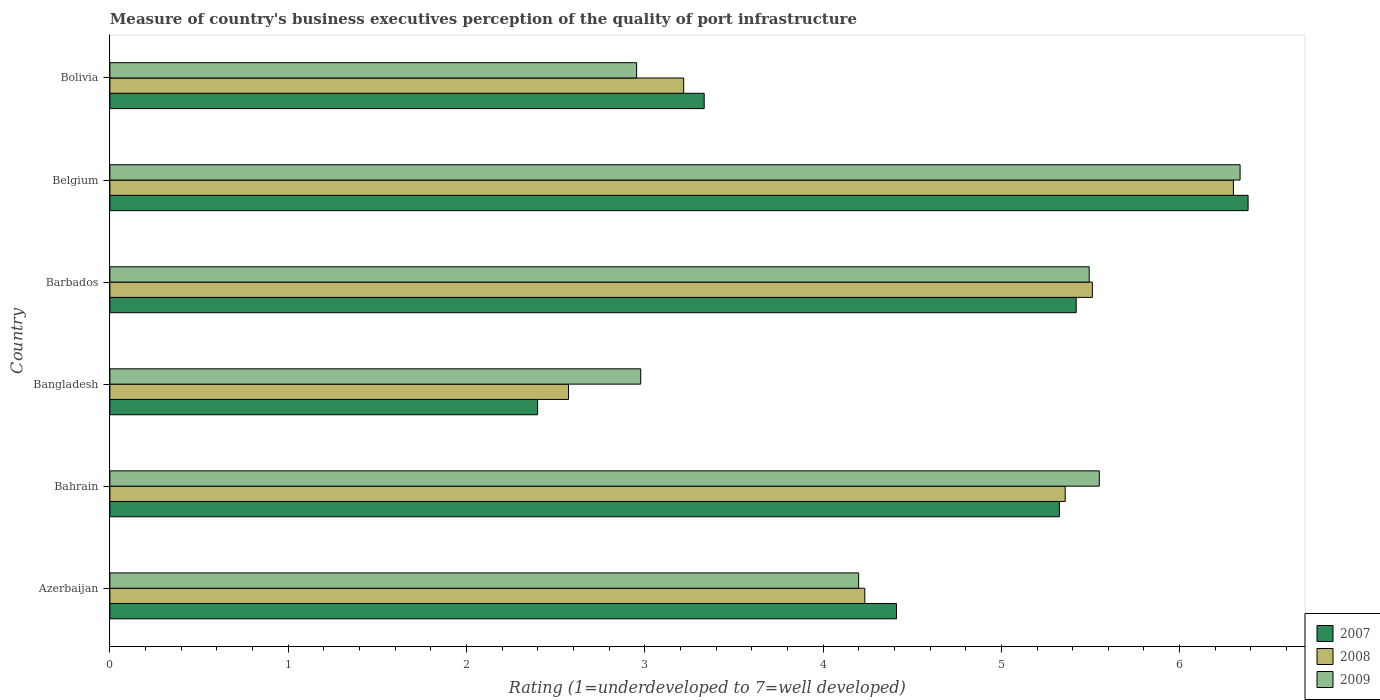How many groups of bars are there?
Your response must be concise. 6. Are the number of bars per tick equal to the number of legend labels?
Ensure brevity in your answer.  Yes. What is the label of the 6th group of bars from the top?
Offer a terse response. Azerbaijan. In how many cases, is the number of bars for a given country not equal to the number of legend labels?
Your answer should be compact. 0. What is the ratings of the quality of port infrastructure in 2008 in Bangladesh?
Give a very brief answer. 2.57. Across all countries, what is the maximum ratings of the quality of port infrastructure in 2009?
Your response must be concise. 6.34. Across all countries, what is the minimum ratings of the quality of port infrastructure in 2008?
Give a very brief answer. 2.57. In which country was the ratings of the quality of port infrastructure in 2008 maximum?
Make the answer very short. Belgium. What is the total ratings of the quality of port infrastructure in 2008 in the graph?
Give a very brief answer. 27.2. What is the difference between the ratings of the quality of port infrastructure in 2007 in Bangladesh and that in Belgium?
Ensure brevity in your answer.  -3.98. What is the difference between the ratings of the quality of port infrastructure in 2009 in Bangladesh and the ratings of the quality of port infrastructure in 2007 in Bolivia?
Offer a very short reply. -0.36. What is the average ratings of the quality of port infrastructure in 2009 per country?
Keep it short and to the point. 4.59. What is the difference between the ratings of the quality of port infrastructure in 2009 and ratings of the quality of port infrastructure in 2007 in Bolivia?
Your answer should be very brief. -0.38. What is the ratio of the ratings of the quality of port infrastructure in 2009 in Azerbaijan to that in Belgium?
Provide a short and direct response. 0.66. Is the ratings of the quality of port infrastructure in 2008 in Bahrain less than that in Bangladesh?
Give a very brief answer. No. Is the difference between the ratings of the quality of port infrastructure in 2009 in Barbados and Bolivia greater than the difference between the ratings of the quality of port infrastructure in 2007 in Barbados and Bolivia?
Give a very brief answer. Yes. What is the difference between the highest and the second highest ratings of the quality of port infrastructure in 2008?
Keep it short and to the point. 0.79. What is the difference between the highest and the lowest ratings of the quality of port infrastructure in 2008?
Your answer should be very brief. 3.73. In how many countries, is the ratings of the quality of port infrastructure in 2009 greater than the average ratings of the quality of port infrastructure in 2009 taken over all countries?
Give a very brief answer. 3. What does the 1st bar from the top in Bahrain represents?
Offer a very short reply. 2009. Is it the case that in every country, the sum of the ratings of the quality of port infrastructure in 2008 and ratings of the quality of port infrastructure in 2009 is greater than the ratings of the quality of port infrastructure in 2007?
Provide a short and direct response. Yes. What is the difference between two consecutive major ticks on the X-axis?
Provide a short and direct response. 1. Does the graph contain grids?
Make the answer very short. No. How many legend labels are there?
Provide a succinct answer. 3. How are the legend labels stacked?
Give a very brief answer. Vertical. What is the title of the graph?
Provide a short and direct response. Measure of country's business executives perception of the quality of port infrastructure. What is the label or title of the X-axis?
Give a very brief answer. Rating (1=underdeveloped to 7=well developed). What is the Rating (1=underdeveloped to 7=well developed) of 2007 in Azerbaijan?
Make the answer very short. 4.41. What is the Rating (1=underdeveloped to 7=well developed) in 2008 in Azerbaijan?
Offer a very short reply. 4.23. What is the Rating (1=underdeveloped to 7=well developed) in 2009 in Azerbaijan?
Offer a very short reply. 4.2. What is the Rating (1=underdeveloped to 7=well developed) in 2007 in Bahrain?
Give a very brief answer. 5.33. What is the Rating (1=underdeveloped to 7=well developed) of 2008 in Bahrain?
Your answer should be very brief. 5.36. What is the Rating (1=underdeveloped to 7=well developed) in 2009 in Bahrain?
Ensure brevity in your answer.  5.55. What is the Rating (1=underdeveloped to 7=well developed) in 2007 in Bangladesh?
Your response must be concise. 2.4. What is the Rating (1=underdeveloped to 7=well developed) in 2008 in Bangladesh?
Make the answer very short. 2.57. What is the Rating (1=underdeveloped to 7=well developed) of 2009 in Bangladesh?
Keep it short and to the point. 2.98. What is the Rating (1=underdeveloped to 7=well developed) of 2007 in Barbados?
Give a very brief answer. 5.42. What is the Rating (1=underdeveloped to 7=well developed) in 2008 in Barbados?
Your answer should be compact. 5.51. What is the Rating (1=underdeveloped to 7=well developed) of 2009 in Barbados?
Offer a very short reply. 5.49. What is the Rating (1=underdeveloped to 7=well developed) in 2007 in Belgium?
Offer a terse response. 6.38. What is the Rating (1=underdeveloped to 7=well developed) of 2008 in Belgium?
Offer a terse response. 6.3. What is the Rating (1=underdeveloped to 7=well developed) of 2009 in Belgium?
Give a very brief answer. 6.34. What is the Rating (1=underdeveloped to 7=well developed) in 2007 in Bolivia?
Your answer should be compact. 3.33. What is the Rating (1=underdeveloped to 7=well developed) of 2008 in Bolivia?
Provide a short and direct response. 3.22. What is the Rating (1=underdeveloped to 7=well developed) of 2009 in Bolivia?
Ensure brevity in your answer.  2.95. Across all countries, what is the maximum Rating (1=underdeveloped to 7=well developed) of 2007?
Keep it short and to the point. 6.38. Across all countries, what is the maximum Rating (1=underdeveloped to 7=well developed) in 2008?
Your answer should be compact. 6.3. Across all countries, what is the maximum Rating (1=underdeveloped to 7=well developed) of 2009?
Make the answer very short. 6.34. Across all countries, what is the minimum Rating (1=underdeveloped to 7=well developed) of 2007?
Give a very brief answer. 2.4. Across all countries, what is the minimum Rating (1=underdeveloped to 7=well developed) of 2008?
Your answer should be compact. 2.57. Across all countries, what is the minimum Rating (1=underdeveloped to 7=well developed) in 2009?
Your response must be concise. 2.95. What is the total Rating (1=underdeveloped to 7=well developed) in 2007 in the graph?
Provide a short and direct response. 27.27. What is the total Rating (1=underdeveloped to 7=well developed) in 2008 in the graph?
Your answer should be compact. 27.2. What is the total Rating (1=underdeveloped to 7=well developed) of 2009 in the graph?
Make the answer very short. 27.51. What is the difference between the Rating (1=underdeveloped to 7=well developed) of 2007 in Azerbaijan and that in Bahrain?
Keep it short and to the point. -0.91. What is the difference between the Rating (1=underdeveloped to 7=well developed) in 2008 in Azerbaijan and that in Bahrain?
Give a very brief answer. -1.12. What is the difference between the Rating (1=underdeveloped to 7=well developed) in 2009 in Azerbaijan and that in Bahrain?
Your response must be concise. -1.35. What is the difference between the Rating (1=underdeveloped to 7=well developed) of 2007 in Azerbaijan and that in Bangladesh?
Your answer should be very brief. 2.01. What is the difference between the Rating (1=underdeveloped to 7=well developed) in 2008 in Azerbaijan and that in Bangladesh?
Keep it short and to the point. 1.66. What is the difference between the Rating (1=underdeveloped to 7=well developed) of 2009 in Azerbaijan and that in Bangladesh?
Provide a short and direct response. 1.22. What is the difference between the Rating (1=underdeveloped to 7=well developed) in 2007 in Azerbaijan and that in Barbados?
Offer a terse response. -1.01. What is the difference between the Rating (1=underdeveloped to 7=well developed) in 2008 in Azerbaijan and that in Barbados?
Provide a succinct answer. -1.28. What is the difference between the Rating (1=underdeveloped to 7=well developed) in 2009 in Azerbaijan and that in Barbados?
Offer a terse response. -1.29. What is the difference between the Rating (1=underdeveloped to 7=well developed) in 2007 in Azerbaijan and that in Belgium?
Offer a very short reply. -1.97. What is the difference between the Rating (1=underdeveloped to 7=well developed) in 2008 in Azerbaijan and that in Belgium?
Your answer should be compact. -2.07. What is the difference between the Rating (1=underdeveloped to 7=well developed) of 2009 in Azerbaijan and that in Belgium?
Make the answer very short. -2.14. What is the difference between the Rating (1=underdeveloped to 7=well developed) in 2007 in Azerbaijan and that in Bolivia?
Your response must be concise. 1.08. What is the difference between the Rating (1=underdeveloped to 7=well developed) of 2008 in Azerbaijan and that in Bolivia?
Offer a terse response. 1.02. What is the difference between the Rating (1=underdeveloped to 7=well developed) of 2009 in Azerbaijan and that in Bolivia?
Your response must be concise. 1.25. What is the difference between the Rating (1=underdeveloped to 7=well developed) of 2007 in Bahrain and that in Bangladesh?
Ensure brevity in your answer.  2.93. What is the difference between the Rating (1=underdeveloped to 7=well developed) in 2008 in Bahrain and that in Bangladesh?
Your response must be concise. 2.79. What is the difference between the Rating (1=underdeveloped to 7=well developed) of 2009 in Bahrain and that in Bangladesh?
Make the answer very short. 2.57. What is the difference between the Rating (1=underdeveloped to 7=well developed) in 2007 in Bahrain and that in Barbados?
Your response must be concise. -0.09. What is the difference between the Rating (1=underdeveloped to 7=well developed) of 2008 in Bahrain and that in Barbados?
Provide a short and direct response. -0.15. What is the difference between the Rating (1=underdeveloped to 7=well developed) in 2009 in Bahrain and that in Barbados?
Offer a very short reply. 0.06. What is the difference between the Rating (1=underdeveloped to 7=well developed) in 2007 in Bahrain and that in Belgium?
Your answer should be compact. -1.06. What is the difference between the Rating (1=underdeveloped to 7=well developed) in 2008 in Bahrain and that in Belgium?
Your answer should be compact. -0.94. What is the difference between the Rating (1=underdeveloped to 7=well developed) of 2009 in Bahrain and that in Belgium?
Keep it short and to the point. -0.79. What is the difference between the Rating (1=underdeveloped to 7=well developed) of 2007 in Bahrain and that in Bolivia?
Your answer should be very brief. 1.99. What is the difference between the Rating (1=underdeveloped to 7=well developed) in 2008 in Bahrain and that in Bolivia?
Ensure brevity in your answer.  2.14. What is the difference between the Rating (1=underdeveloped to 7=well developed) in 2009 in Bahrain and that in Bolivia?
Ensure brevity in your answer.  2.6. What is the difference between the Rating (1=underdeveloped to 7=well developed) of 2007 in Bangladesh and that in Barbados?
Your answer should be compact. -3.02. What is the difference between the Rating (1=underdeveloped to 7=well developed) of 2008 in Bangladesh and that in Barbados?
Provide a short and direct response. -2.94. What is the difference between the Rating (1=underdeveloped to 7=well developed) of 2009 in Bangladesh and that in Barbados?
Your answer should be compact. -2.52. What is the difference between the Rating (1=underdeveloped to 7=well developed) of 2007 in Bangladesh and that in Belgium?
Your answer should be very brief. -3.98. What is the difference between the Rating (1=underdeveloped to 7=well developed) in 2008 in Bangladesh and that in Belgium?
Your answer should be compact. -3.73. What is the difference between the Rating (1=underdeveloped to 7=well developed) of 2009 in Bangladesh and that in Belgium?
Provide a succinct answer. -3.36. What is the difference between the Rating (1=underdeveloped to 7=well developed) in 2007 in Bangladesh and that in Bolivia?
Provide a succinct answer. -0.93. What is the difference between the Rating (1=underdeveloped to 7=well developed) in 2008 in Bangladesh and that in Bolivia?
Ensure brevity in your answer.  -0.65. What is the difference between the Rating (1=underdeveloped to 7=well developed) in 2009 in Bangladesh and that in Bolivia?
Provide a short and direct response. 0.02. What is the difference between the Rating (1=underdeveloped to 7=well developed) of 2007 in Barbados and that in Belgium?
Ensure brevity in your answer.  -0.96. What is the difference between the Rating (1=underdeveloped to 7=well developed) in 2008 in Barbados and that in Belgium?
Offer a terse response. -0.79. What is the difference between the Rating (1=underdeveloped to 7=well developed) in 2009 in Barbados and that in Belgium?
Your response must be concise. -0.85. What is the difference between the Rating (1=underdeveloped to 7=well developed) of 2007 in Barbados and that in Bolivia?
Keep it short and to the point. 2.09. What is the difference between the Rating (1=underdeveloped to 7=well developed) of 2008 in Barbados and that in Bolivia?
Your answer should be very brief. 2.29. What is the difference between the Rating (1=underdeveloped to 7=well developed) in 2009 in Barbados and that in Bolivia?
Make the answer very short. 2.54. What is the difference between the Rating (1=underdeveloped to 7=well developed) in 2007 in Belgium and that in Bolivia?
Ensure brevity in your answer.  3.05. What is the difference between the Rating (1=underdeveloped to 7=well developed) of 2008 in Belgium and that in Bolivia?
Provide a succinct answer. 3.08. What is the difference between the Rating (1=underdeveloped to 7=well developed) of 2009 in Belgium and that in Bolivia?
Keep it short and to the point. 3.38. What is the difference between the Rating (1=underdeveloped to 7=well developed) in 2007 in Azerbaijan and the Rating (1=underdeveloped to 7=well developed) in 2008 in Bahrain?
Provide a succinct answer. -0.95. What is the difference between the Rating (1=underdeveloped to 7=well developed) in 2007 in Azerbaijan and the Rating (1=underdeveloped to 7=well developed) in 2009 in Bahrain?
Give a very brief answer. -1.14. What is the difference between the Rating (1=underdeveloped to 7=well developed) of 2008 in Azerbaijan and the Rating (1=underdeveloped to 7=well developed) of 2009 in Bahrain?
Provide a succinct answer. -1.32. What is the difference between the Rating (1=underdeveloped to 7=well developed) of 2007 in Azerbaijan and the Rating (1=underdeveloped to 7=well developed) of 2008 in Bangladesh?
Offer a very short reply. 1.84. What is the difference between the Rating (1=underdeveloped to 7=well developed) in 2007 in Azerbaijan and the Rating (1=underdeveloped to 7=well developed) in 2009 in Bangladesh?
Ensure brevity in your answer.  1.43. What is the difference between the Rating (1=underdeveloped to 7=well developed) of 2008 in Azerbaijan and the Rating (1=underdeveloped to 7=well developed) of 2009 in Bangladesh?
Keep it short and to the point. 1.26. What is the difference between the Rating (1=underdeveloped to 7=well developed) of 2007 in Azerbaijan and the Rating (1=underdeveloped to 7=well developed) of 2008 in Barbados?
Your response must be concise. -1.1. What is the difference between the Rating (1=underdeveloped to 7=well developed) in 2007 in Azerbaijan and the Rating (1=underdeveloped to 7=well developed) in 2009 in Barbados?
Make the answer very short. -1.08. What is the difference between the Rating (1=underdeveloped to 7=well developed) of 2008 in Azerbaijan and the Rating (1=underdeveloped to 7=well developed) of 2009 in Barbados?
Your answer should be very brief. -1.26. What is the difference between the Rating (1=underdeveloped to 7=well developed) in 2007 in Azerbaijan and the Rating (1=underdeveloped to 7=well developed) in 2008 in Belgium?
Offer a terse response. -1.89. What is the difference between the Rating (1=underdeveloped to 7=well developed) in 2007 in Azerbaijan and the Rating (1=underdeveloped to 7=well developed) in 2009 in Belgium?
Ensure brevity in your answer.  -1.93. What is the difference between the Rating (1=underdeveloped to 7=well developed) in 2008 in Azerbaijan and the Rating (1=underdeveloped to 7=well developed) in 2009 in Belgium?
Offer a terse response. -2.1. What is the difference between the Rating (1=underdeveloped to 7=well developed) of 2007 in Azerbaijan and the Rating (1=underdeveloped to 7=well developed) of 2008 in Bolivia?
Provide a short and direct response. 1.19. What is the difference between the Rating (1=underdeveloped to 7=well developed) of 2007 in Azerbaijan and the Rating (1=underdeveloped to 7=well developed) of 2009 in Bolivia?
Your answer should be very brief. 1.46. What is the difference between the Rating (1=underdeveloped to 7=well developed) of 2008 in Azerbaijan and the Rating (1=underdeveloped to 7=well developed) of 2009 in Bolivia?
Give a very brief answer. 1.28. What is the difference between the Rating (1=underdeveloped to 7=well developed) of 2007 in Bahrain and the Rating (1=underdeveloped to 7=well developed) of 2008 in Bangladesh?
Ensure brevity in your answer.  2.75. What is the difference between the Rating (1=underdeveloped to 7=well developed) of 2007 in Bahrain and the Rating (1=underdeveloped to 7=well developed) of 2009 in Bangladesh?
Keep it short and to the point. 2.35. What is the difference between the Rating (1=underdeveloped to 7=well developed) of 2008 in Bahrain and the Rating (1=underdeveloped to 7=well developed) of 2009 in Bangladesh?
Your answer should be very brief. 2.38. What is the difference between the Rating (1=underdeveloped to 7=well developed) of 2007 in Bahrain and the Rating (1=underdeveloped to 7=well developed) of 2008 in Barbados?
Offer a very short reply. -0.18. What is the difference between the Rating (1=underdeveloped to 7=well developed) in 2007 in Bahrain and the Rating (1=underdeveloped to 7=well developed) in 2009 in Barbados?
Provide a succinct answer. -0.17. What is the difference between the Rating (1=underdeveloped to 7=well developed) of 2008 in Bahrain and the Rating (1=underdeveloped to 7=well developed) of 2009 in Barbados?
Provide a succinct answer. -0.13. What is the difference between the Rating (1=underdeveloped to 7=well developed) in 2007 in Bahrain and the Rating (1=underdeveloped to 7=well developed) in 2008 in Belgium?
Your response must be concise. -0.98. What is the difference between the Rating (1=underdeveloped to 7=well developed) in 2007 in Bahrain and the Rating (1=underdeveloped to 7=well developed) in 2009 in Belgium?
Keep it short and to the point. -1.01. What is the difference between the Rating (1=underdeveloped to 7=well developed) in 2008 in Bahrain and the Rating (1=underdeveloped to 7=well developed) in 2009 in Belgium?
Offer a very short reply. -0.98. What is the difference between the Rating (1=underdeveloped to 7=well developed) in 2007 in Bahrain and the Rating (1=underdeveloped to 7=well developed) in 2008 in Bolivia?
Your answer should be compact. 2.11. What is the difference between the Rating (1=underdeveloped to 7=well developed) in 2007 in Bahrain and the Rating (1=underdeveloped to 7=well developed) in 2009 in Bolivia?
Give a very brief answer. 2.37. What is the difference between the Rating (1=underdeveloped to 7=well developed) of 2008 in Bahrain and the Rating (1=underdeveloped to 7=well developed) of 2009 in Bolivia?
Your answer should be very brief. 2.4. What is the difference between the Rating (1=underdeveloped to 7=well developed) of 2007 in Bangladesh and the Rating (1=underdeveloped to 7=well developed) of 2008 in Barbados?
Make the answer very short. -3.11. What is the difference between the Rating (1=underdeveloped to 7=well developed) in 2007 in Bangladesh and the Rating (1=underdeveloped to 7=well developed) in 2009 in Barbados?
Provide a succinct answer. -3.09. What is the difference between the Rating (1=underdeveloped to 7=well developed) in 2008 in Bangladesh and the Rating (1=underdeveloped to 7=well developed) in 2009 in Barbados?
Your answer should be very brief. -2.92. What is the difference between the Rating (1=underdeveloped to 7=well developed) of 2007 in Bangladesh and the Rating (1=underdeveloped to 7=well developed) of 2008 in Belgium?
Give a very brief answer. -3.9. What is the difference between the Rating (1=underdeveloped to 7=well developed) in 2007 in Bangladesh and the Rating (1=underdeveloped to 7=well developed) in 2009 in Belgium?
Offer a terse response. -3.94. What is the difference between the Rating (1=underdeveloped to 7=well developed) in 2008 in Bangladesh and the Rating (1=underdeveloped to 7=well developed) in 2009 in Belgium?
Make the answer very short. -3.77. What is the difference between the Rating (1=underdeveloped to 7=well developed) of 2007 in Bangladesh and the Rating (1=underdeveloped to 7=well developed) of 2008 in Bolivia?
Your answer should be very brief. -0.82. What is the difference between the Rating (1=underdeveloped to 7=well developed) of 2007 in Bangladesh and the Rating (1=underdeveloped to 7=well developed) of 2009 in Bolivia?
Keep it short and to the point. -0.56. What is the difference between the Rating (1=underdeveloped to 7=well developed) of 2008 in Bangladesh and the Rating (1=underdeveloped to 7=well developed) of 2009 in Bolivia?
Your answer should be compact. -0.38. What is the difference between the Rating (1=underdeveloped to 7=well developed) of 2007 in Barbados and the Rating (1=underdeveloped to 7=well developed) of 2008 in Belgium?
Your answer should be compact. -0.88. What is the difference between the Rating (1=underdeveloped to 7=well developed) in 2007 in Barbados and the Rating (1=underdeveloped to 7=well developed) in 2009 in Belgium?
Give a very brief answer. -0.92. What is the difference between the Rating (1=underdeveloped to 7=well developed) in 2008 in Barbados and the Rating (1=underdeveloped to 7=well developed) in 2009 in Belgium?
Make the answer very short. -0.83. What is the difference between the Rating (1=underdeveloped to 7=well developed) of 2007 in Barbados and the Rating (1=underdeveloped to 7=well developed) of 2008 in Bolivia?
Make the answer very short. 2.2. What is the difference between the Rating (1=underdeveloped to 7=well developed) in 2007 in Barbados and the Rating (1=underdeveloped to 7=well developed) in 2009 in Bolivia?
Your answer should be compact. 2.47. What is the difference between the Rating (1=underdeveloped to 7=well developed) in 2008 in Barbados and the Rating (1=underdeveloped to 7=well developed) in 2009 in Bolivia?
Your response must be concise. 2.56. What is the difference between the Rating (1=underdeveloped to 7=well developed) of 2007 in Belgium and the Rating (1=underdeveloped to 7=well developed) of 2008 in Bolivia?
Provide a succinct answer. 3.17. What is the difference between the Rating (1=underdeveloped to 7=well developed) of 2007 in Belgium and the Rating (1=underdeveloped to 7=well developed) of 2009 in Bolivia?
Keep it short and to the point. 3.43. What is the difference between the Rating (1=underdeveloped to 7=well developed) of 2008 in Belgium and the Rating (1=underdeveloped to 7=well developed) of 2009 in Bolivia?
Provide a short and direct response. 3.35. What is the average Rating (1=underdeveloped to 7=well developed) in 2007 per country?
Your answer should be very brief. 4.55. What is the average Rating (1=underdeveloped to 7=well developed) of 2008 per country?
Keep it short and to the point. 4.53. What is the average Rating (1=underdeveloped to 7=well developed) in 2009 per country?
Make the answer very short. 4.59. What is the difference between the Rating (1=underdeveloped to 7=well developed) in 2007 and Rating (1=underdeveloped to 7=well developed) in 2008 in Azerbaijan?
Your answer should be very brief. 0.18. What is the difference between the Rating (1=underdeveloped to 7=well developed) in 2007 and Rating (1=underdeveloped to 7=well developed) in 2009 in Azerbaijan?
Provide a succinct answer. 0.21. What is the difference between the Rating (1=underdeveloped to 7=well developed) of 2008 and Rating (1=underdeveloped to 7=well developed) of 2009 in Azerbaijan?
Provide a succinct answer. 0.03. What is the difference between the Rating (1=underdeveloped to 7=well developed) in 2007 and Rating (1=underdeveloped to 7=well developed) in 2008 in Bahrain?
Give a very brief answer. -0.03. What is the difference between the Rating (1=underdeveloped to 7=well developed) in 2007 and Rating (1=underdeveloped to 7=well developed) in 2009 in Bahrain?
Offer a terse response. -0.22. What is the difference between the Rating (1=underdeveloped to 7=well developed) of 2008 and Rating (1=underdeveloped to 7=well developed) of 2009 in Bahrain?
Your answer should be very brief. -0.19. What is the difference between the Rating (1=underdeveloped to 7=well developed) of 2007 and Rating (1=underdeveloped to 7=well developed) of 2008 in Bangladesh?
Your answer should be very brief. -0.17. What is the difference between the Rating (1=underdeveloped to 7=well developed) of 2007 and Rating (1=underdeveloped to 7=well developed) of 2009 in Bangladesh?
Ensure brevity in your answer.  -0.58. What is the difference between the Rating (1=underdeveloped to 7=well developed) of 2008 and Rating (1=underdeveloped to 7=well developed) of 2009 in Bangladesh?
Give a very brief answer. -0.41. What is the difference between the Rating (1=underdeveloped to 7=well developed) of 2007 and Rating (1=underdeveloped to 7=well developed) of 2008 in Barbados?
Provide a short and direct response. -0.09. What is the difference between the Rating (1=underdeveloped to 7=well developed) in 2007 and Rating (1=underdeveloped to 7=well developed) in 2009 in Barbados?
Provide a succinct answer. -0.07. What is the difference between the Rating (1=underdeveloped to 7=well developed) of 2008 and Rating (1=underdeveloped to 7=well developed) of 2009 in Barbados?
Give a very brief answer. 0.02. What is the difference between the Rating (1=underdeveloped to 7=well developed) in 2007 and Rating (1=underdeveloped to 7=well developed) in 2008 in Belgium?
Make the answer very short. 0.08. What is the difference between the Rating (1=underdeveloped to 7=well developed) of 2007 and Rating (1=underdeveloped to 7=well developed) of 2009 in Belgium?
Keep it short and to the point. 0.04. What is the difference between the Rating (1=underdeveloped to 7=well developed) of 2008 and Rating (1=underdeveloped to 7=well developed) of 2009 in Belgium?
Your answer should be very brief. -0.04. What is the difference between the Rating (1=underdeveloped to 7=well developed) in 2007 and Rating (1=underdeveloped to 7=well developed) in 2008 in Bolivia?
Your answer should be very brief. 0.12. What is the difference between the Rating (1=underdeveloped to 7=well developed) in 2007 and Rating (1=underdeveloped to 7=well developed) in 2009 in Bolivia?
Your response must be concise. 0.38. What is the difference between the Rating (1=underdeveloped to 7=well developed) in 2008 and Rating (1=underdeveloped to 7=well developed) in 2009 in Bolivia?
Make the answer very short. 0.26. What is the ratio of the Rating (1=underdeveloped to 7=well developed) of 2007 in Azerbaijan to that in Bahrain?
Offer a very short reply. 0.83. What is the ratio of the Rating (1=underdeveloped to 7=well developed) of 2008 in Azerbaijan to that in Bahrain?
Provide a short and direct response. 0.79. What is the ratio of the Rating (1=underdeveloped to 7=well developed) of 2009 in Azerbaijan to that in Bahrain?
Your answer should be compact. 0.76. What is the ratio of the Rating (1=underdeveloped to 7=well developed) of 2007 in Azerbaijan to that in Bangladesh?
Ensure brevity in your answer.  1.84. What is the ratio of the Rating (1=underdeveloped to 7=well developed) of 2008 in Azerbaijan to that in Bangladesh?
Your answer should be compact. 1.65. What is the ratio of the Rating (1=underdeveloped to 7=well developed) in 2009 in Azerbaijan to that in Bangladesh?
Your response must be concise. 1.41. What is the ratio of the Rating (1=underdeveloped to 7=well developed) of 2007 in Azerbaijan to that in Barbados?
Offer a very short reply. 0.81. What is the ratio of the Rating (1=underdeveloped to 7=well developed) in 2008 in Azerbaijan to that in Barbados?
Give a very brief answer. 0.77. What is the ratio of the Rating (1=underdeveloped to 7=well developed) of 2009 in Azerbaijan to that in Barbados?
Offer a terse response. 0.76. What is the ratio of the Rating (1=underdeveloped to 7=well developed) in 2007 in Azerbaijan to that in Belgium?
Your answer should be compact. 0.69. What is the ratio of the Rating (1=underdeveloped to 7=well developed) in 2008 in Azerbaijan to that in Belgium?
Keep it short and to the point. 0.67. What is the ratio of the Rating (1=underdeveloped to 7=well developed) in 2009 in Azerbaijan to that in Belgium?
Provide a short and direct response. 0.66. What is the ratio of the Rating (1=underdeveloped to 7=well developed) of 2007 in Azerbaijan to that in Bolivia?
Offer a terse response. 1.32. What is the ratio of the Rating (1=underdeveloped to 7=well developed) in 2008 in Azerbaijan to that in Bolivia?
Offer a very short reply. 1.32. What is the ratio of the Rating (1=underdeveloped to 7=well developed) of 2009 in Azerbaijan to that in Bolivia?
Offer a terse response. 1.42. What is the ratio of the Rating (1=underdeveloped to 7=well developed) in 2007 in Bahrain to that in Bangladesh?
Give a very brief answer. 2.22. What is the ratio of the Rating (1=underdeveloped to 7=well developed) of 2008 in Bahrain to that in Bangladesh?
Offer a very short reply. 2.08. What is the ratio of the Rating (1=underdeveloped to 7=well developed) in 2009 in Bahrain to that in Bangladesh?
Your answer should be very brief. 1.86. What is the ratio of the Rating (1=underdeveloped to 7=well developed) of 2007 in Bahrain to that in Barbados?
Provide a short and direct response. 0.98. What is the ratio of the Rating (1=underdeveloped to 7=well developed) in 2008 in Bahrain to that in Barbados?
Your response must be concise. 0.97. What is the ratio of the Rating (1=underdeveloped to 7=well developed) in 2009 in Bahrain to that in Barbados?
Your response must be concise. 1.01. What is the ratio of the Rating (1=underdeveloped to 7=well developed) of 2007 in Bahrain to that in Belgium?
Give a very brief answer. 0.83. What is the ratio of the Rating (1=underdeveloped to 7=well developed) of 2008 in Bahrain to that in Belgium?
Give a very brief answer. 0.85. What is the ratio of the Rating (1=underdeveloped to 7=well developed) of 2009 in Bahrain to that in Belgium?
Provide a succinct answer. 0.88. What is the ratio of the Rating (1=underdeveloped to 7=well developed) of 2007 in Bahrain to that in Bolivia?
Your response must be concise. 1.6. What is the ratio of the Rating (1=underdeveloped to 7=well developed) of 2008 in Bahrain to that in Bolivia?
Your answer should be very brief. 1.66. What is the ratio of the Rating (1=underdeveloped to 7=well developed) of 2009 in Bahrain to that in Bolivia?
Your answer should be very brief. 1.88. What is the ratio of the Rating (1=underdeveloped to 7=well developed) of 2007 in Bangladesh to that in Barbados?
Make the answer very short. 0.44. What is the ratio of the Rating (1=underdeveloped to 7=well developed) in 2008 in Bangladesh to that in Barbados?
Your response must be concise. 0.47. What is the ratio of the Rating (1=underdeveloped to 7=well developed) of 2009 in Bangladesh to that in Barbados?
Offer a terse response. 0.54. What is the ratio of the Rating (1=underdeveloped to 7=well developed) in 2007 in Bangladesh to that in Belgium?
Your answer should be very brief. 0.38. What is the ratio of the Rating (1=underdeveloped to 7=well developed) in 2008 in Bangladesh to that in Belgium?
Make the answer very short. 0.41. What is the ratio of the Rating (1=underdeveloped to 7=well developed) in 2009 in Bangladesh to that in Belgium?
Provide a succinct answer. 0.47. What is the ratio of the Rating (1=underdeveloped to 7=well developed) in 2007 in Bangladesh to that in Bolivia?
Your answer should be very brief. 0.72. What is the ratio of the Rating (1=underdeveloped to 7=well developed) of 2008 in Bangladesh to that in Bolivia?
Provide a short and direct response. 0.8. What is the ratio of the Rating (1=underdeveloped to 7=well developed) in 2009 in Bangladesh to that in Bolivia?
Offer a terse response. 1.01. What is the ratio of the Rating (1=underdeveloped to 7=well developed) of 2007 in Barbados to that in Belgium?
Your response must be concise. 0.85. What is the ratio of the Rating (1=underdeveloped to 7=well developed) of 2008 in Barbados to that in Belgium?
Make the answer very short. 0.87. What is the ratio of the Rating (1=underdeveloped to 7=well developed) of 2009 in Barbados to that in Belgium?
Provide a short and direct response. 0.87. What is the ratio of the Rating (1=underdeveloped to 7=well developed) of 2007 in Barbados to that in Bolivia?
Your response must be concise. 1.63. What is the ratio of the Rating (1=underdeveloped to 7=well developed) in 2008 in Barbados to that in Bolivia?
Your response must be concise. 1.71. What is the ratio of the Rating (1=underdeveloped to 7=well developed) in 2009 in Barbados to that in Bolivia?
Your response must be concise. 1.86. What is the ratio of the Rating (1=underdeveloped to 7=well developed) of 2007 in Belgium to that in Bolivia?
Make the answer very short. 1.92. What is the ratio of the Rating (1=underdeveloped to 7=well developed) in 2008 in Belgium to that in Bolivia?
Ensure brevity in your answer.  1.96. What is the ratio of the Rating (1=underdeveloped to 7=well developed) in 2009 in Belgium to that in Bolivia?
Your response must be concise. 2.15. What is the difference between the highest and the second highest Rating (1=underdeveloped to 7=well developed) of 2007?
Your answer should be compact. 0.96. What is the difference between the highest and the second highest Rating (1=underdeveloped to 7=well developed) of 2008?
Your answer should be compact. 0.79. What is the difference between the highest and the second highest Rating (1=underdeveloped to 7=well developed) of 2009?
Offer a terse response. 0.79. What is the difference between the highest and the lowest Rating (1=underdeveloped to 7=well developed) in 2007?
Provide a short and direct response. 3.98. What is the difference between the highest and the lowest Rating (1=underdeveloped to 7=well developed) of 2008?
Provide a short and direct response. 3.73. What is the difference between the highest and the lowest Rating (1=underdeveloped to 7=well developed) of 2009?
Ensure brevity in your answer.  3.38. 